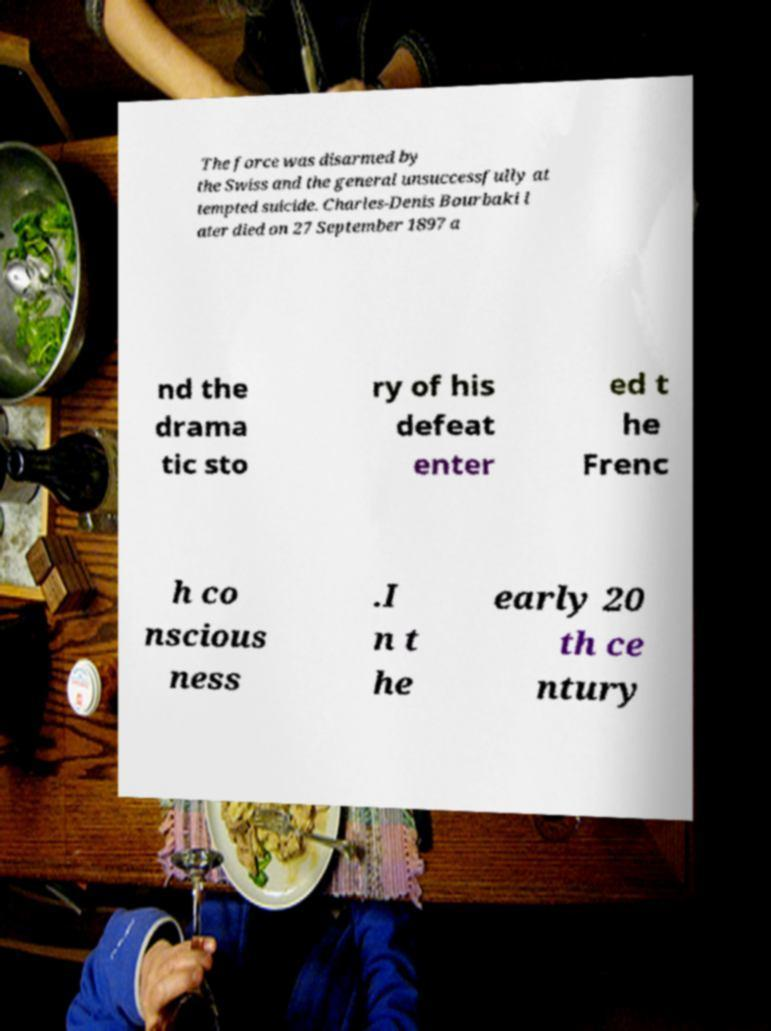Could you assist in decoding the text presented in this image and type it out clearly? The force was disarmed by the Swiss and the general unsuccessfully at tempted suicide. Charles-Denis Bourbaki l ater died on 27 September 1897 a nd the drama tic sto ry of his defeat enter ed t he Frenc h co nscious ness .I n t he early 20 th ce ntury 